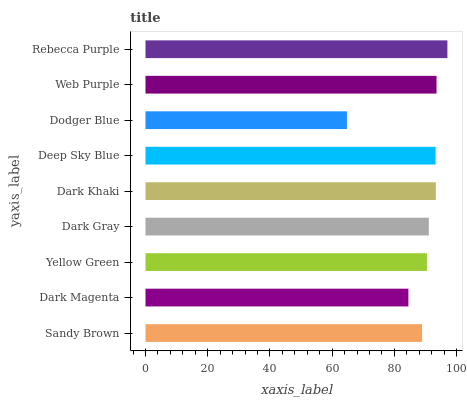Is Dodger Blue the minimum?
Answer yes or no. Yes. Is Rebecca Purple the maximum?
Answer yes or no. Yes. Is Dark Magenta the minimum?
Answer yes or no. No. Is Dark Magenta the maximum?
Answer yes or no. No. Is Sandy Brown greater than Dark Magenta?
Answer yes or no. Yes. Is Dark Magenta less than Sandy Brown?
Answer yes or no. Yes. Is Dark Magenta greater than Sandy Brown?
Answer yes or no. No. Is Sandy Brown less than Dark Magenta?
Answer yes or no. No. Is Dark Gray the high median?
Answer yes or no. Yes. Is Dark Gray the low median?
Answer yes or no. Yes. Is Dodger Blue the high median?
Answer yes or no. No. Is Dodger Blue the low median?
Answer yes or no. No. 